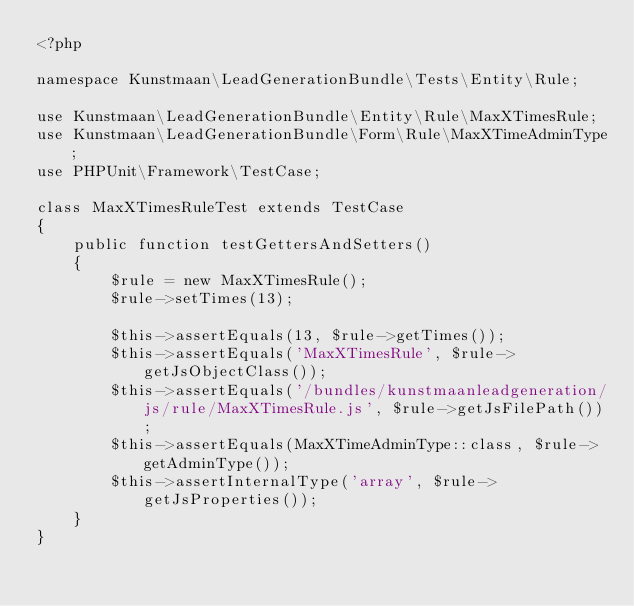<code> <loc_0><loc_0><loc_500><loc_500><_PHP_><?php

namespace Kunstmaan\LeadGenerationBundle\Tests\Entity\Rule;

use Kunstmaan\LeadGenerationBundle\Entity\Rule\MaxXTimesRule;
use Kunstmaan\LeadGenerationBundle\Form\Rule\MaxXTimeAdminType;
use PHPUnit\Framework\TestCase;

class MaxXTimesRuleTest extends TestCase
{
    public function testGettersAndSetters()
    {
        $rule = new MaxXTimesRule();
        $rule->setTimes(13);

        $this->assertEquals(13, $rule->getTimes());
        $this->assertEquals('MaxXTimesRule', $rule->getJsObjectClass());
        $this->assertEquals('/bundles/kunstmaanleadgeneration/js/rule/MaxXTimesRule.js', $rule->getJsFilePath());
        $this->assertEquals(MaxXTimeAdminType::class, $rule->getAdminType());
        $this->assertInternalType('array', $rule->getJsProperties());
    }
}
</code> 